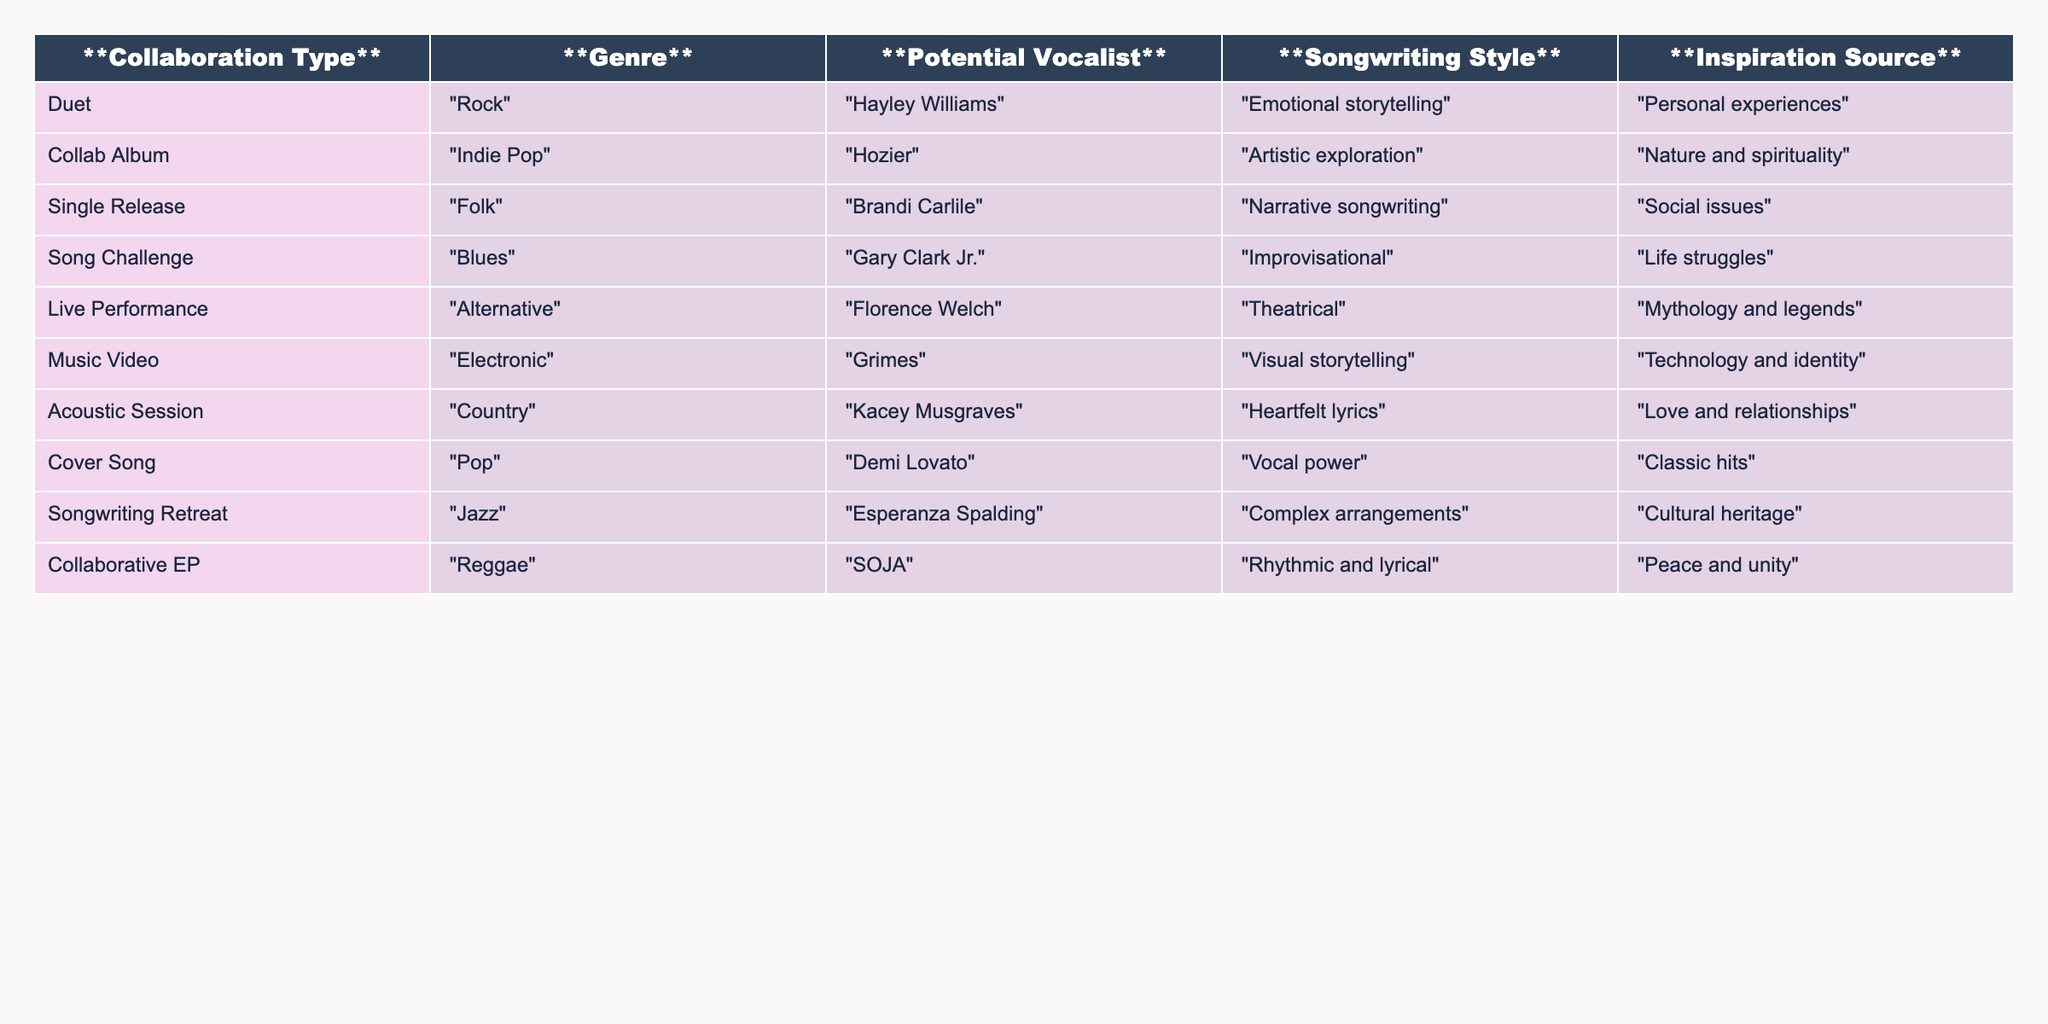What is the potential vocalist for the "Duet" collaboration type? In the table, under the "Collaboration Type" column, the "Duet" entry has "Hayley Williams" listed as the potential vocalist.
Answer: Hayley Williams Which genre is associated with Kacey Musgraves? Kacey Musgraves is listed under the "Collaborative Type" for "Acoustic Session," which is associated with the "Country" genre.
Answer: Country Is "Brandi Carlile" involved in any collaboration type that focuses on social issues? The table indicates that "Brandi Carlile" is associated with the "Single Release" collaboration type, which mentions "Social issues" as the inspiration source, confirming her involvement.
Answer: Yes What type of songwriting style does "Florence Welch" represent in the table? In the row for "Live Performance," "Florence Welch" is noted for "Theatrical" songwriting style.
Answer: Theatrical Which potential vocalist is linked to the "Collaborative EP"? According to the table, "SOJA" is listed as the potential vocalist for the "Collaborative EP."
Answer: SOJA Are there any collaboration types that focus on emotional storytelling? The table shows that the "Duet" collaboration type with "Hayley Williams" focuses on emotional storytelling, confirming there is such a type.
Answer: Yes What are the inspiration sources for the "Song Challenge"? The "Song Challenge" collaboration type refers to "Life struggles" as its inspiration source.
Answer: Life struggles Calculate how many different genres are represented in the table. The unique genres listed in the table are Rock, Indie Pop, Folk, Blues, Alternative, Electronic, Country, Pop, Jazz, and Reggae, totaling 10 distinct genres.
Answer: 10 Which two collaboration types include the theme of nature and spirituality? The "Collab Album" with "Hozier" and the "Acoustic Session" with "Kacey Musgraves" are both associated with inspiration from nature and spirituality themes.
Answer: Collab Album and Acoustic Session What is the main songwriting style associated with "Grimes"? "Grimes" is associated with "Visual storytelling" as the songwriting style under the "Music Video" collaboration type.
Answer: Visual storytelling 